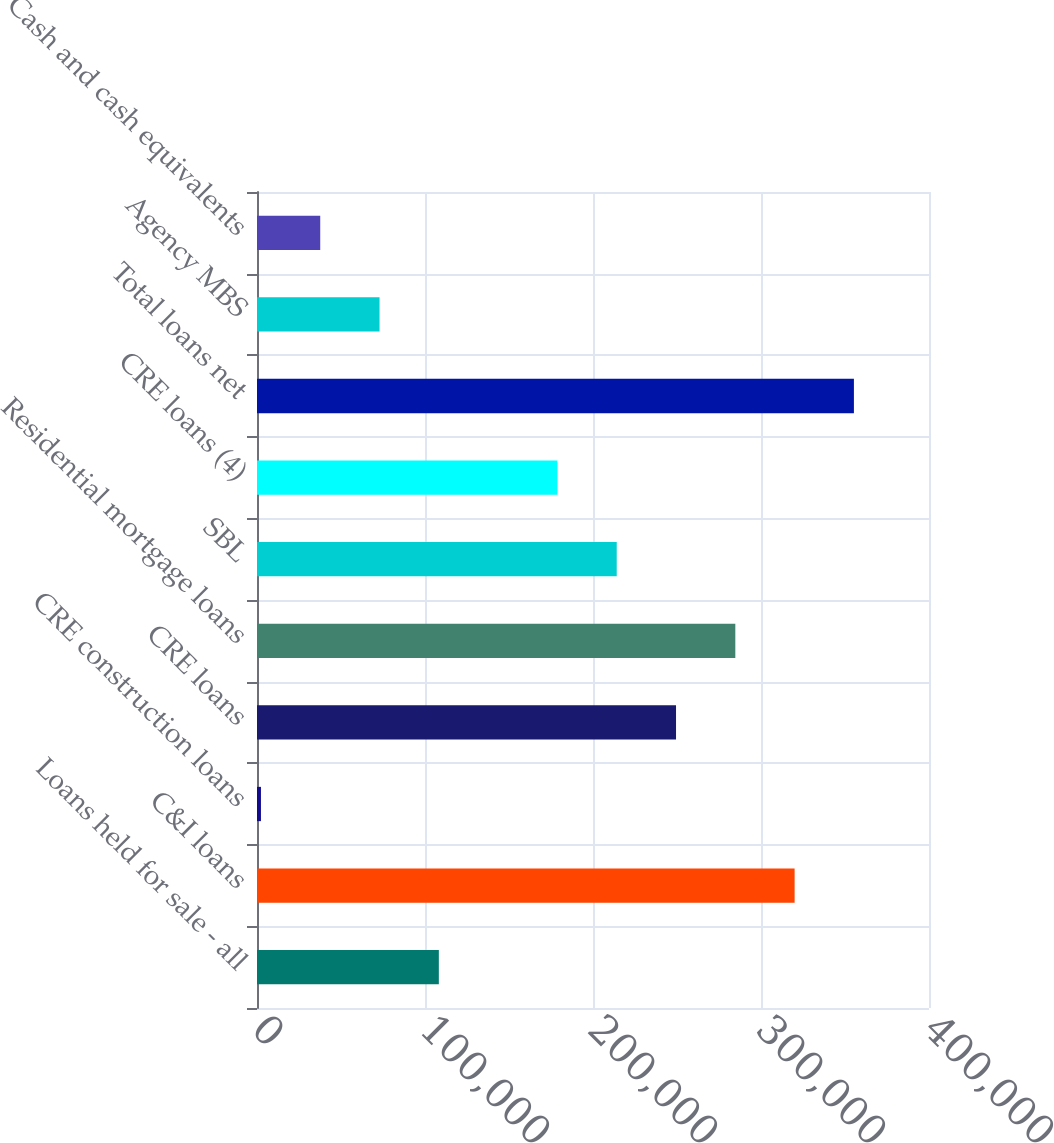Convert chart to OTSL. <chart><loc_0><loc_0><loc_500><loc_500><bar_chart><fcel>Loans held for sale - all<fcel>C&I loans<fcel>CRE construction loans<fcel>CRE loans<fcel>Residential mortgage loans<fcel>SBL<fcel>CRE loans (4)<fcel>Total loans net<fcel>Agency MBS<fcel>Cash and cash equivalents<nl><fcel>108233<fcel>320008<fcel>2346<fcel>249417<fcel>284712<fcel>214121<fcel>178825<fcel>355304<fcel>72937.6<fcel>37641.8<nl></chart> 